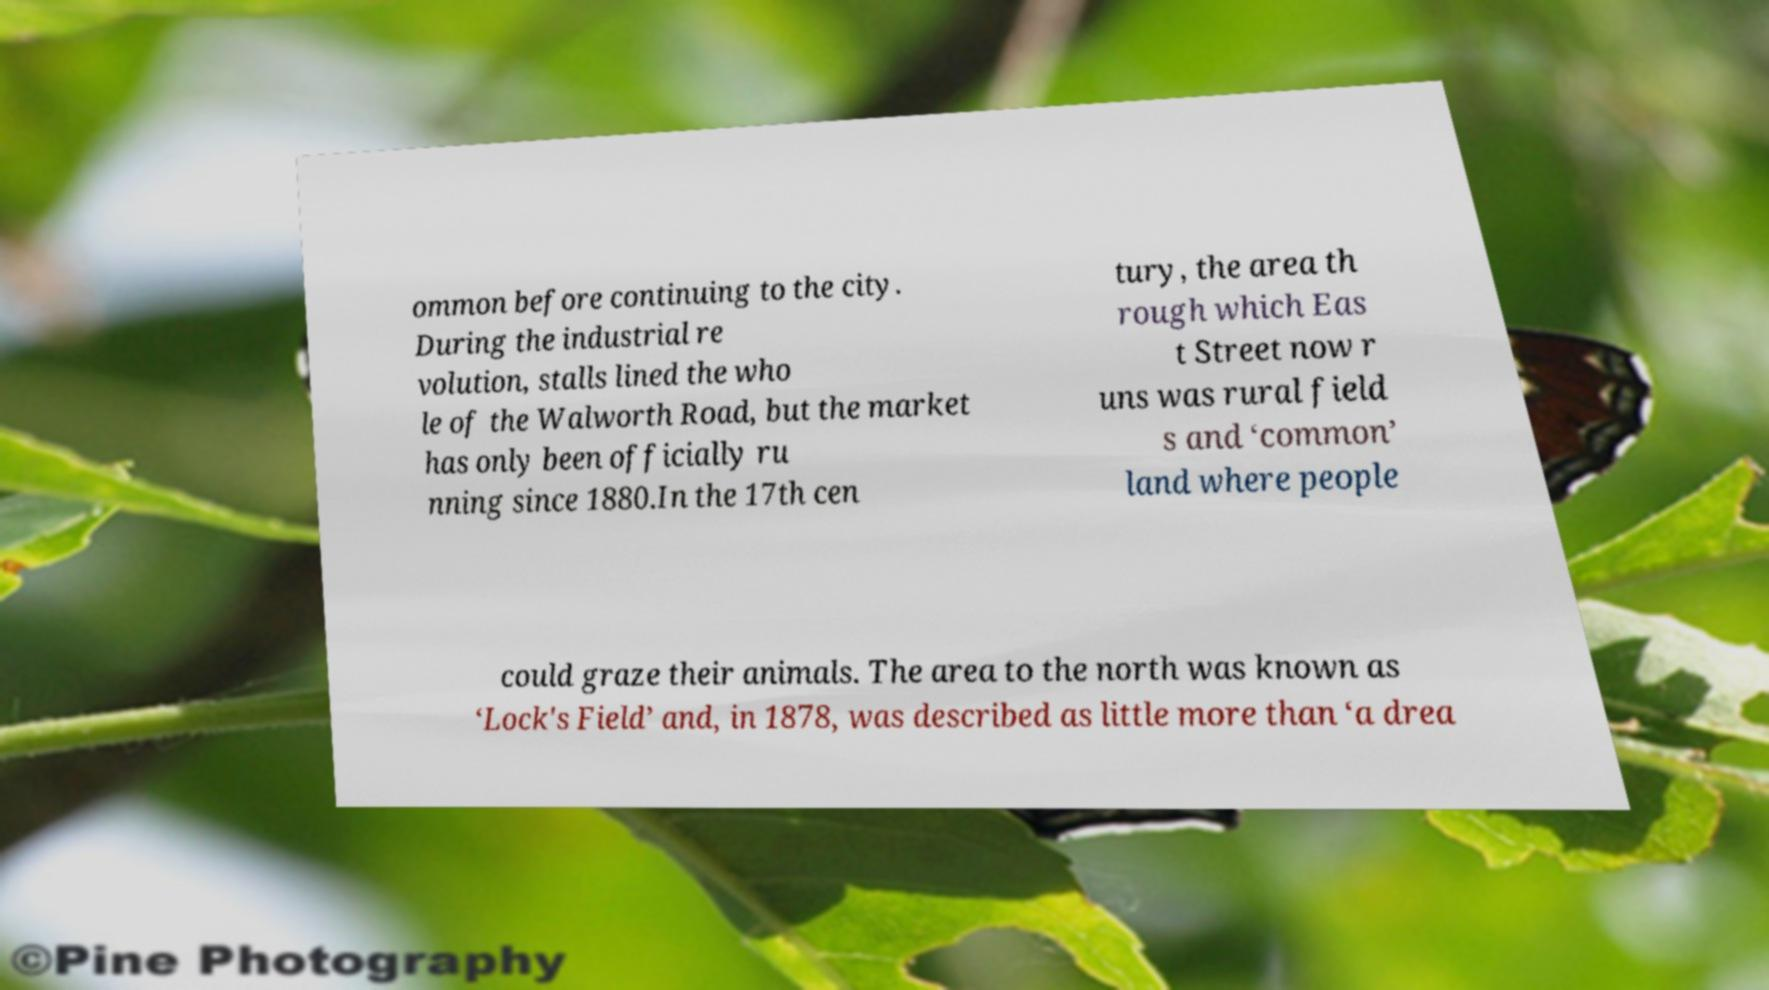I need the written content from this picture converted into text. Can you do that? ommon before continuing to the city. During the industrial re volution, stalls lined the who le of the Walworth Road, but the market has only been officially ru nning since 1880.In the 17th cen tury, the area th rough which Eas t Street now r uns was rural field s and ‘common’ land where people could graze their animals. The area to the north was known as ‘Lock's Field’ and, in 1878, was described as little more than ‘a drea 